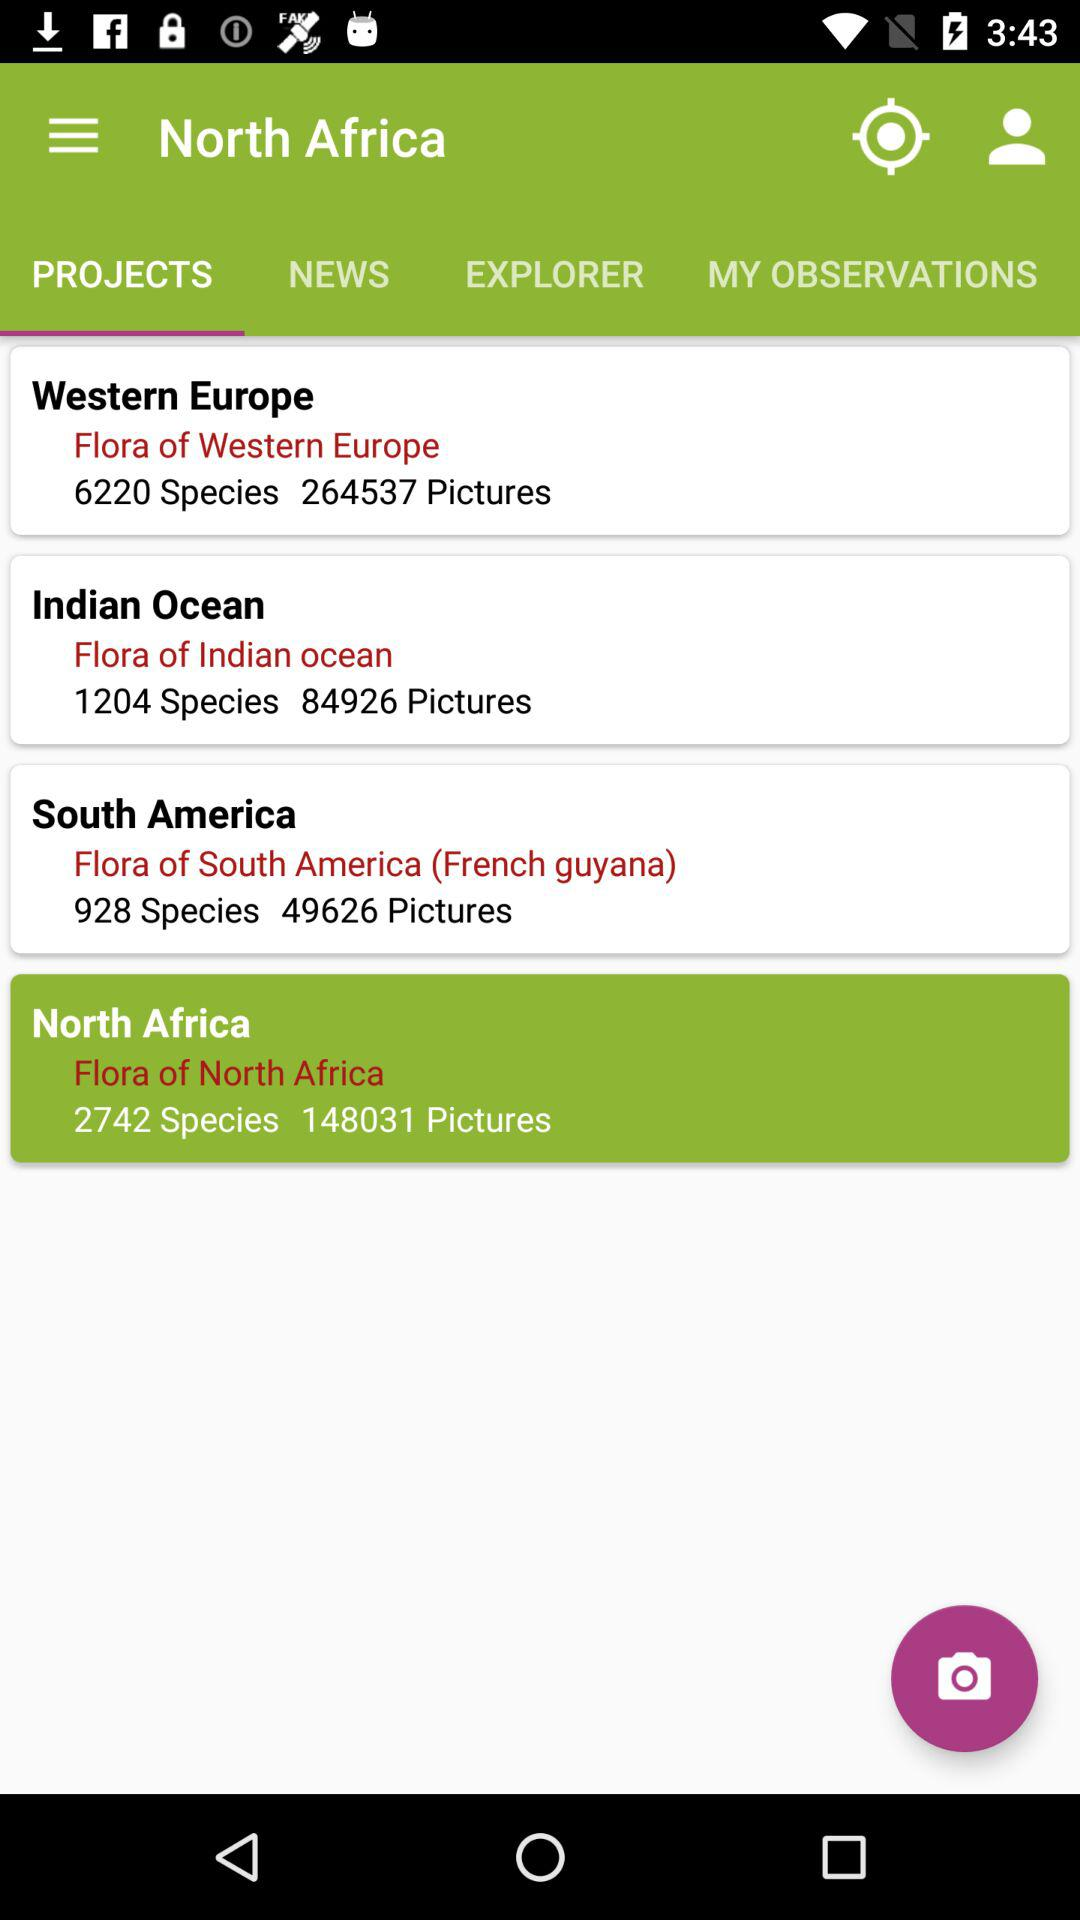What is the total number of species in the "Flora of Indian ocean"? The total number of species in the "Flora of Indian ocean" is 1204. 